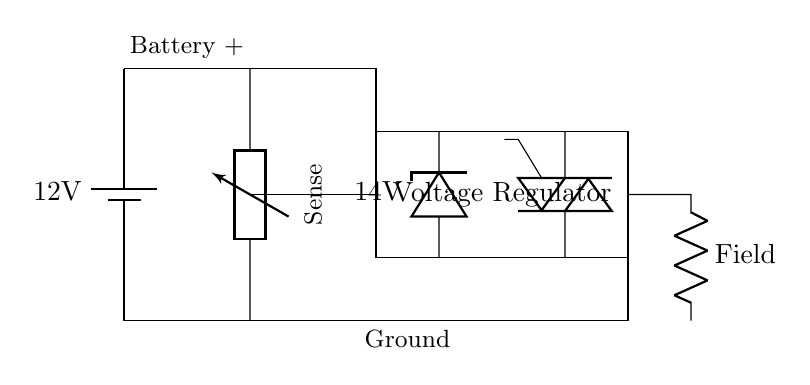What is the voltage of the battery? The circuit shows a battery symbol labeled with "12V", indicating its voltage.
Answer: 12V What is the purpose of the Zener diode in this circuit? A Zener diode regulates the voltage at a steady value, specified here as "14V", helping to maintain consistent voltage levels for battery charging.
Answer: Voltage regulation What component produces the electrical power in this circuit? The alternator is depicted as a tgeneric element in the circuit, which is responsible for generating electrical power.
Answer: Alternator What is the current drawn by the field component? The field component is represented by a resistor in the circuit; however, the current value is not explicitly labeled, indicating that it must be inferred or measured in practice.
Answer: Not specified How does the voltage regulator connect to the alternator? The voltage regulator is connected at the upper level to the alternator via connected lines, ensuring it receives the generated power for regulation.
Answer: Direct connection What is the role of the transistor (Q1) in this circuit? The transistor is utilized in the voltage regulator section to control the current flow based on the feedback from the circuit, thus helping to regulate the voltage output.
Answer: Current control What is the output voltage level maintained by the Zener diode? The Zener diode is labeled with "14V", indicating that it clamps the voltage output to this specific level for the battery charging condition.
Answer: 14V 